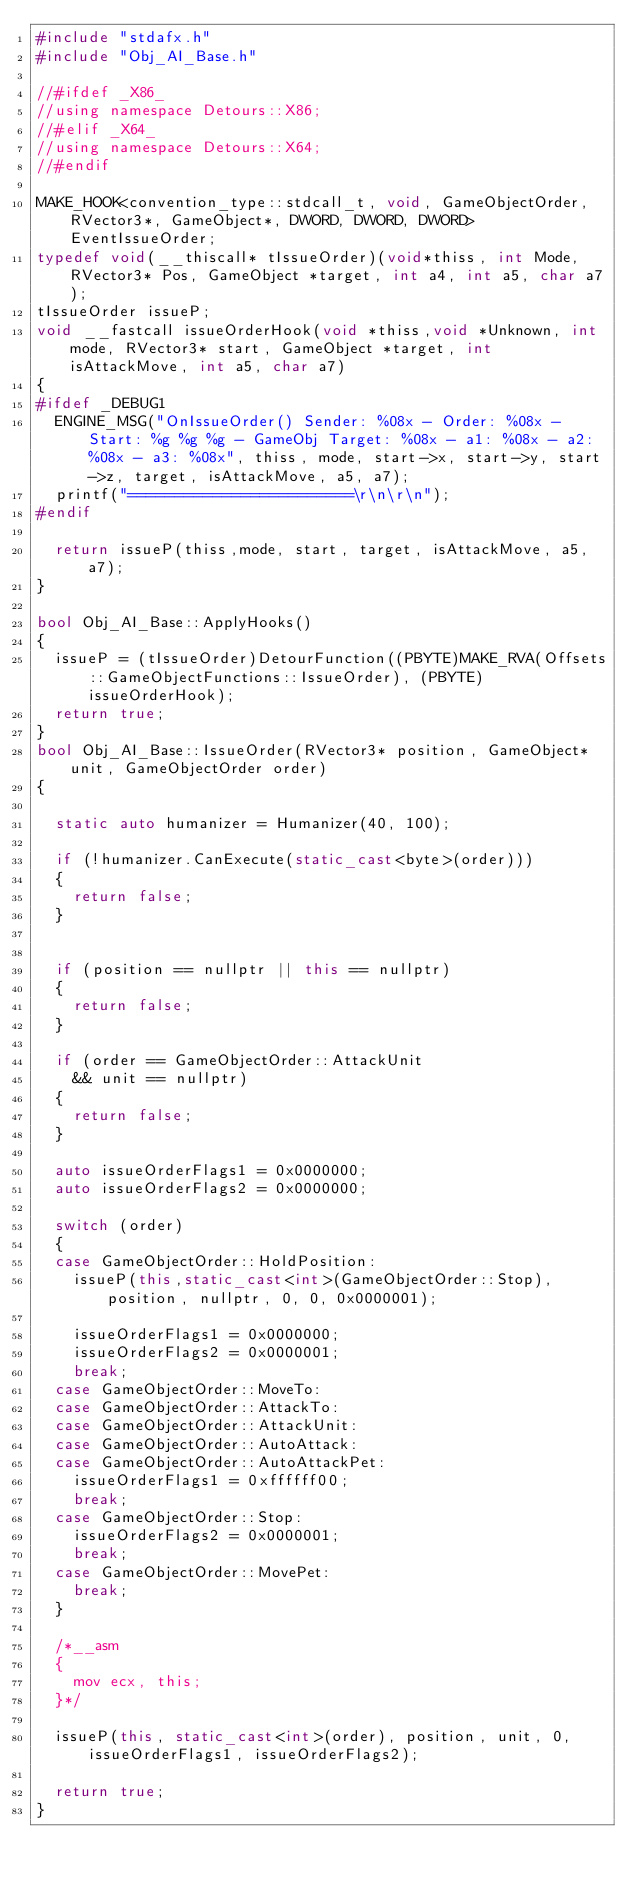<code> <loc_0><loc_0><loc_500><loc_500><_C++_>#include "stdafx.h"
#include "Obj_AI_Base.h"

//#ifdef _X86_
//using namespace Detours::X86;
//#elif _X64_
//using namespace Detours::X64;
//#endif

MAKE_HOOK<convention_type::stdcall_t, void, GameObjectOrder, RVector3*, GameObject*, DWORD, DWORD, DWORD> EventIssueOrder;
typedef void(__thiscall* tIssueOrder)(void*thiss, int Mode, RVector3* Pos, GameObject *target, int a4, int a5, char a7);
tIssueOrder issueP;
void __fastcall issueOrderHook(void *thiss,void *Unknown, int mode, RVector3* start, GameObject *target, int isAttackMove, int a5, char a7)
{
#ifdef _DEBUG1
	ENGINE_MSG("OnIssueOrder() Sender: %08x - Order: %08x - Start: %g %g %g - GameObj Target: %08x - a1: %08x - a2: %08x - a3: %08x", thiss, mode, start->x, start->y, start->z, target, isAttackMove, a5, a7);
	printf("========================\r\n\r\n");
#endif

	return issueP(thiss,mode, start, target, isAttackMove, a5, a7);
}

bool Obj_AI_Base::ApplyHooks()
{
	issueP = (tIssueOrder)DetourFunction((PBYTE)MAKE_RVA(Offsets::GameObjectFunctions::IssueOrder), (PBYTE)issueOrderHook);
	return true;	
}
bool Obj_AI_Base::IssueOrder(RVector3* position, GameObject* unit, GameObjectOrder order)
{

	static auto humanizer = Humanizer(40, 100);

	if (!humanizer.CanExecute(static_cast<byte>(order)))
	{
		return false;
	}


	if (position == nullptr || this == nullptr)
	{
		return false;
	}

	if (order == GameObjectOrder::AttackUnit
		&& unit == nullptr)
	{
		return false;
	}

	auto issueOrderFlags1 = 0x0000000;
	auto issueOrderFlags2 = 0x0000000;

	switch (order)
	{
	case GameObjectOrder::HoldPosition:
		issueP(this,static_cast<int>(GameObjectOrder::Stop), position, nullptr, 0, 0, 0x0000001);

		issueOrderFlags1 = 0x0000000;
		issueOrderFlags2 = 0x0000001;
		break;
	case GameObjectOrder::MoveTo:
	case GameObjectOrder::AttackTo:
	case GameObjectOrder::AttackUnit:
	case GameObjectOrder::AutoAttack:
	case GameObjectOrder::AutoAttackPet:
		issueOrderFlags1 = 0xffffff00;
		break;
	case GameObjectOrder::Stop:
		issueOrderFlags2 = 0x0000001;
		break;
	case GameObjectOrder::MovePet:
		break;
	}

	/*__asm
	{
		mov ecx, this;
	}*/

	issueP(this, static_cast<int>(order), position, unit, 0, issueOrderFlags1, issueOrderFlags2);

	return true;
}</code> 